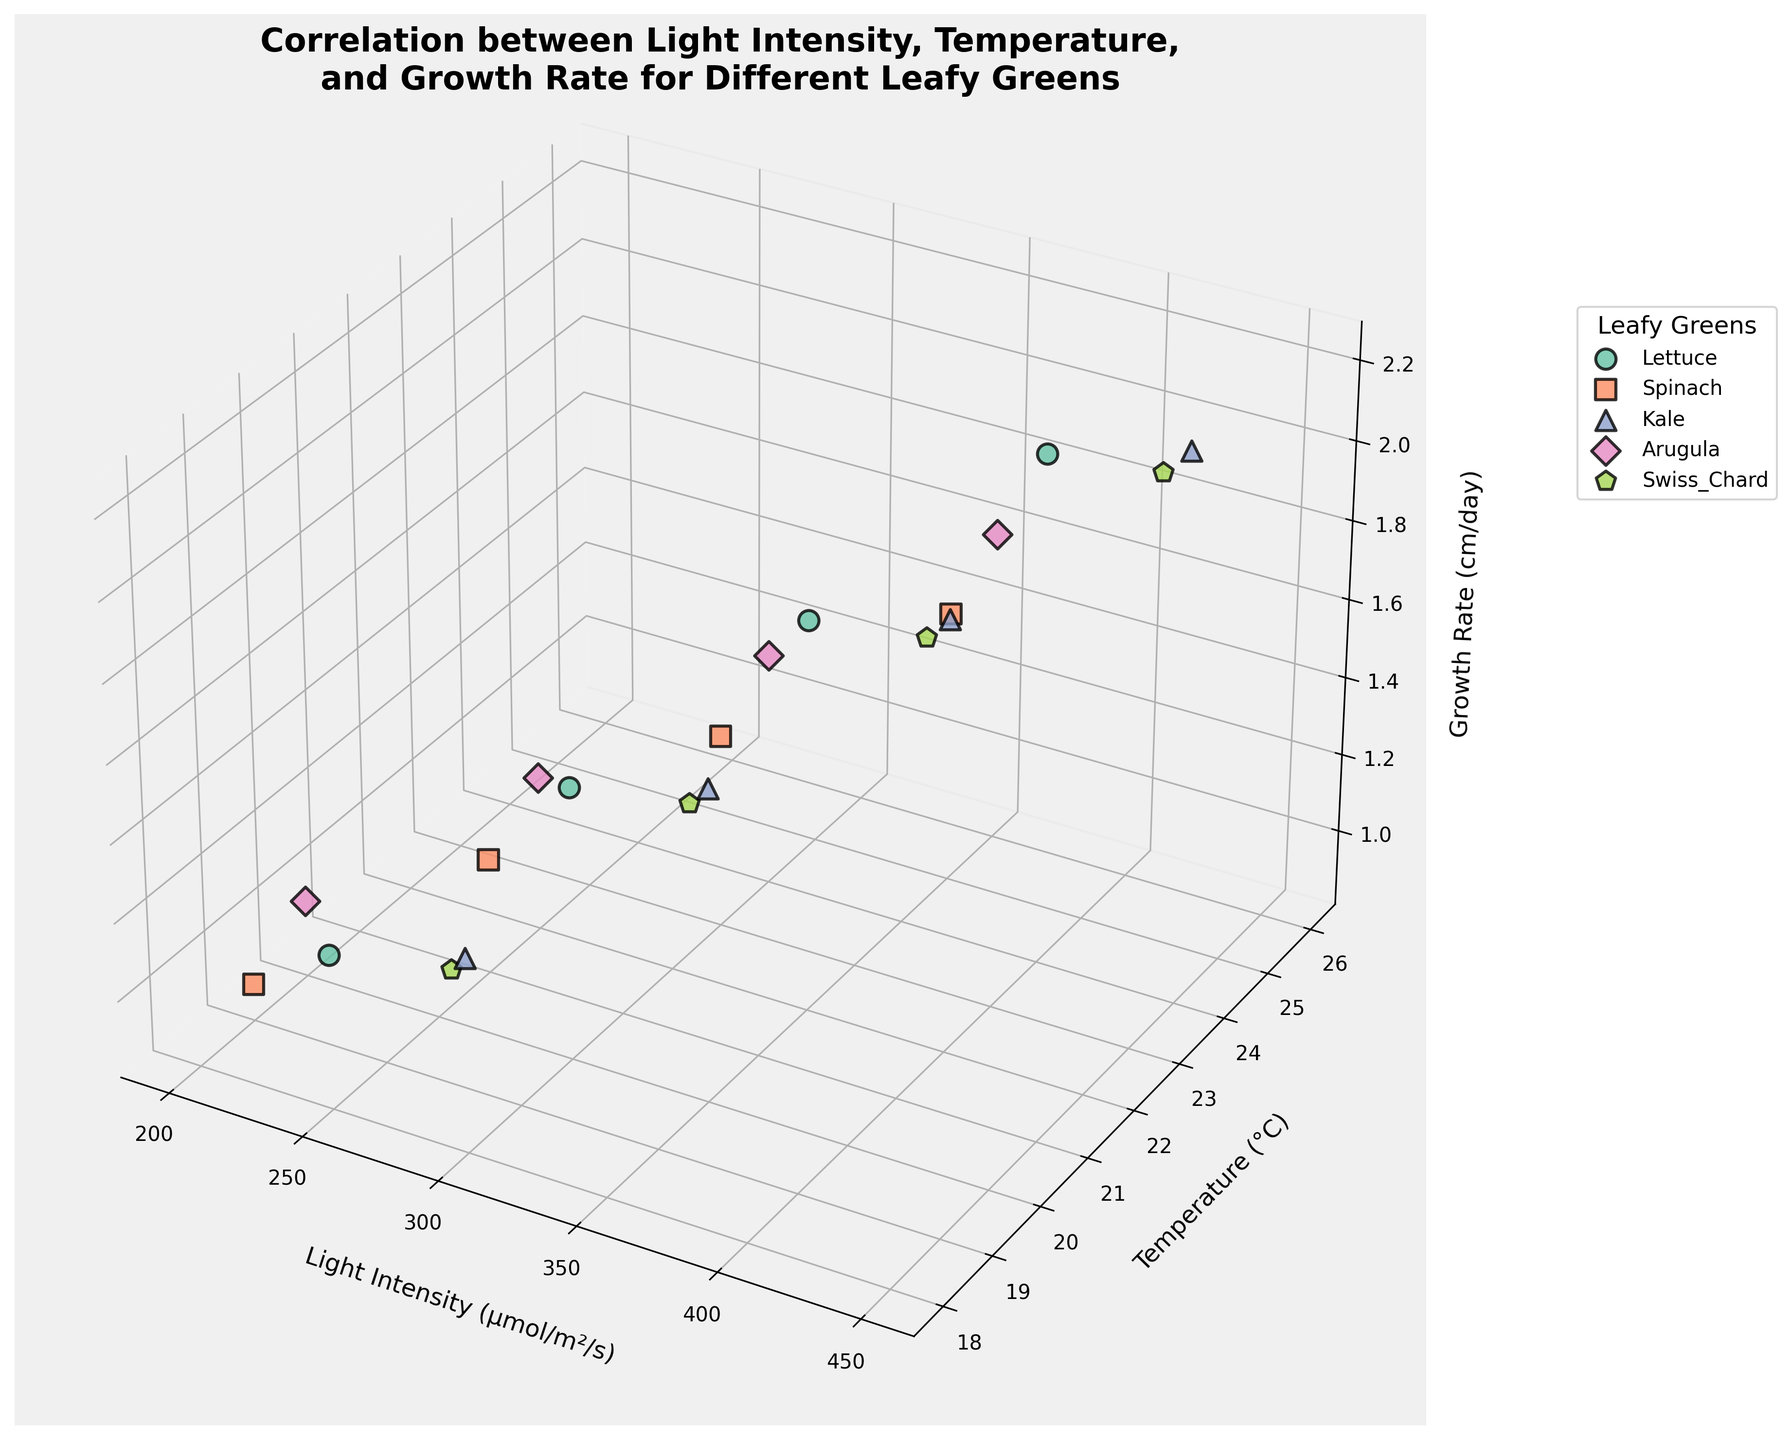What's the title of the figure? The title of the figure is prominently displayed at the top of the plot, providing a summary of what the data represents. The title reads, "Correlation between Light Intensity, Temperature, and Growth Rate for Different Leafy Greens".
Answer: Correlation between Light Intensity, Temperature, and Growth Rate for Different Leafy Greens Which leafy green has the highest growth rate and what are the corresponding light intensity and temperature? By visually inspecting the plot, the data point with the highest position along the Z-axis (Growth Rate) corresponds to Kale, at around 2.2 cm/day. The light intensity is around 450 μmol/m²/s, and the temperature is around 24°C.
Answer: Kale, 450, 24 What is the general trend observed as light intensity increases for Lettuce? As the light intensity increases (X-axis) for Lettuce (light green points), the data points generally move higher along the Z-axis (Growth Rate) and to the right along the Y-axis (Temperature). This indicates that growth rate increases with higher light intensity, and this increase is also associated with higher temperatures.
Answer: Growth rate increases Which leafy green has the least growth rate and under what conditions is this observed? The data point with the lowest growth rate is found by looking at the lowest position on the Z-axis. The lowest growth rate is observed in Spinach, at around 0.9 cm/day, with a light intensity of 200 μmol/m²/s and a temperature of 19°C.
Answer: Spinach, 200, 19 Compare the growth rate of Spinach and Arugula at light intensities around 200 and 250 μmol/m²/s and at temperatures of 19°C and 20°C for Spinach and 20°C and 22°C for Arugula. Which leafy green shows better growth? Looking at the points for Spinach and Arugula in the specified conditions, we observe that at around 200 and 250 μmol/m²/s, Spinach's growth rates are approximately 0.9 and 1.1 cm/day, while Arugula's growth rates are around 1.0 and 1.2 cm/day. Thus, Arugula shows slightly better growth rates under these conditions.
Answer: Arugula What can you infer about the relationship between temperature and growth rate for Kale? Kale’s data points show that as the temperature increases (Y-axis), the growth rate (Z-axis) also tends to increase. Specifically, higher temperatures seem to be associated with better growth rates.
Answer: Positive correlation Which two leafy greens have overlapping growth rates at varying temperatures and how can you differentiate them? Lettuce and Kale have overlapping growth rates around 1.8 to 2.1 cm/day. You can differentiate them based on the color of the data points (Lettuce: light green, Kale: light blue) and their associated markers (Lettuce: circles, Kale: triangles).
Answer: Lettuce and Kale What is the growth rate difference between the highest and lowest growth rate observed for Swiss Chard? The highest growth rate for Swiss Chard is around 2.0 cm/day (light intensity 425 μmol/m²/s, temperature 25°C) and the lowest is around 1.1 cm/day (light intensity 275 μmol/m²/s, temperature 19°C). The difference is 2.0 - 1.1 = 0.9 cm/day.
Answer: 0.9 cm/day 